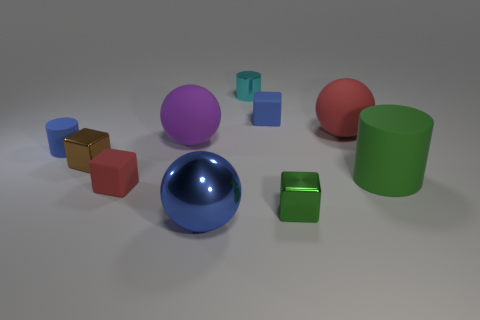Subtract all tiny cyan cylinders. How many cylinders are left? 2 Subtract all blocks. How many objects are left? 6 Add 1 matte blocks. How many matte blocks are left? 3 Add 4 large yellow metal things. How many large yellow metal things exist? 4 Subtract all blue spheres. How many spheres are left? 2 Subtract 0 green spheres. How many objects are left? 10 Subtract 1 spheres. How many spheres are left? 2 Subtract all cyan cylinders. Subtract all yellow spheres. How many cylinders are left? 2 Subtract all blue balls. How many green blocks are left? 1 Subtract all red matte spheres. Subtract all small blue cubes. How many objects are left? 8 